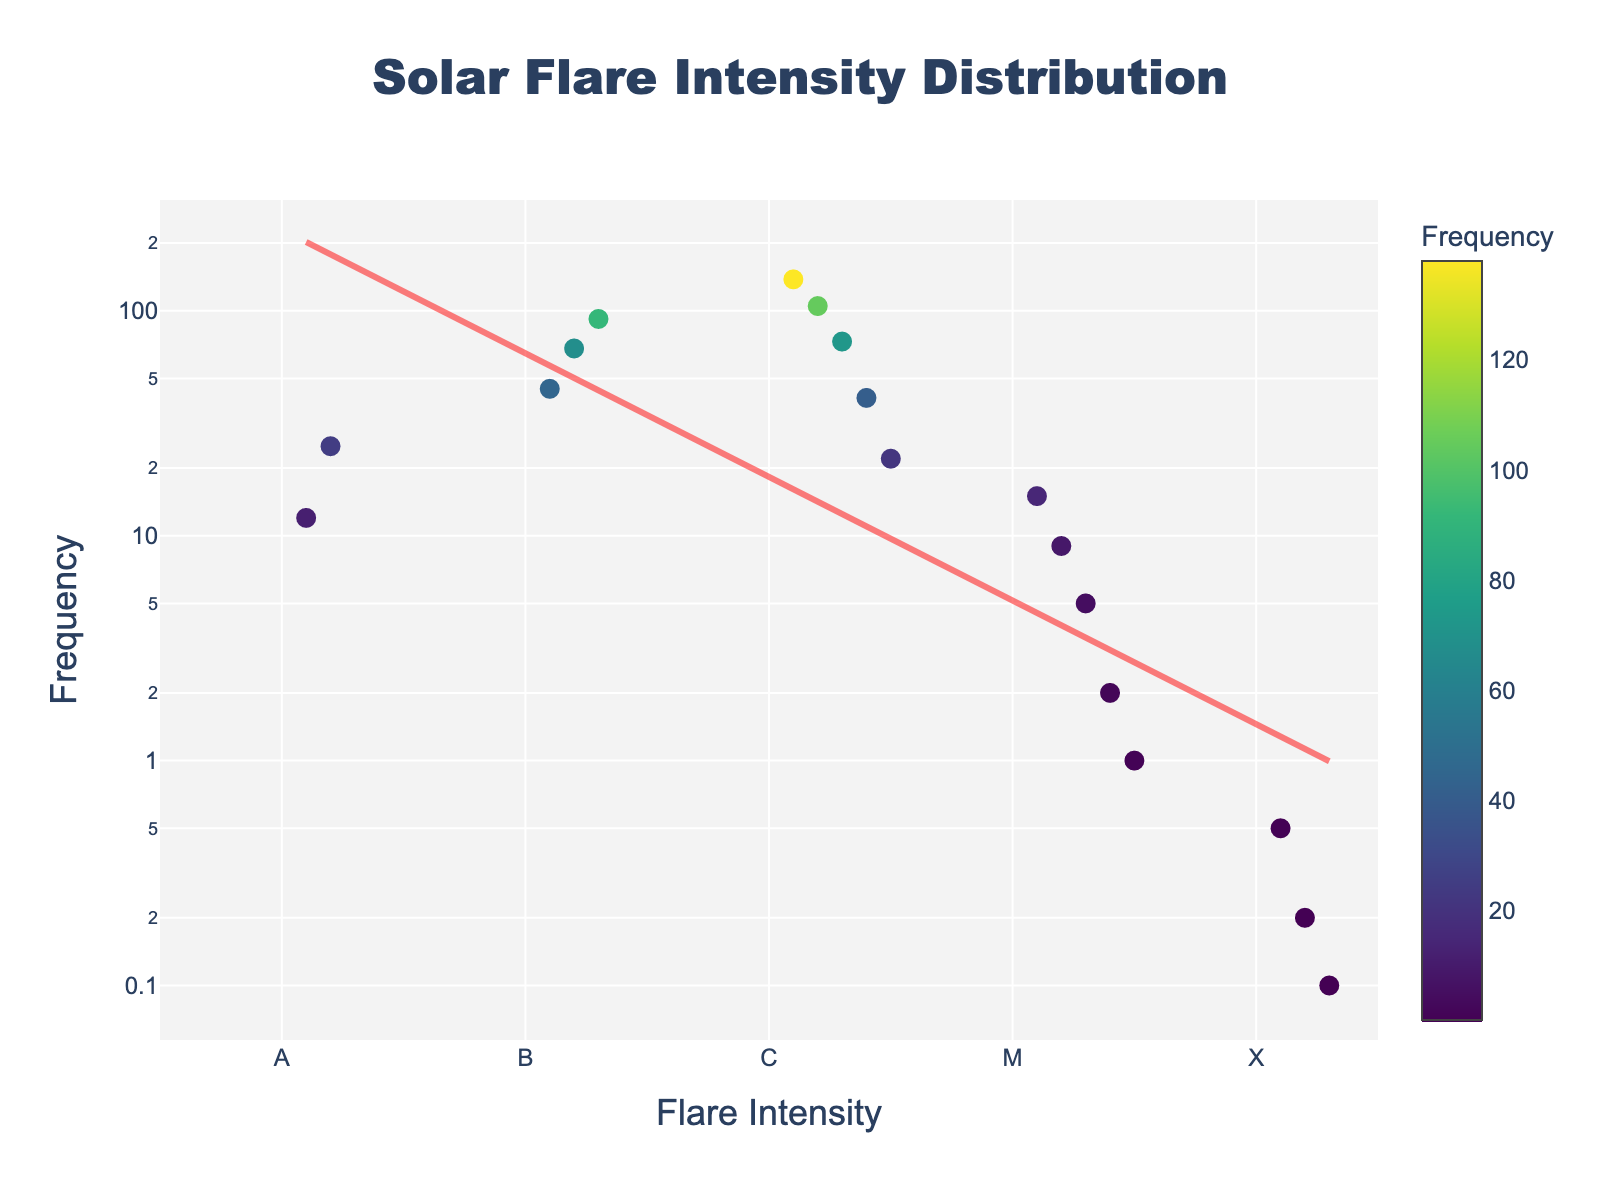what is the title of the plot? The text at the top center of the plot displays the title. It states: "Solar Flare Intensity Distribution".
Answer: Solar Flare Intensity Distribution What is the frequency of solar flares with intensity M1? Hovering over the marker labeled 'M1' reveals the frequency displayed next to the intensity level. It shows a frequency of 15.
Answer: 15 What is the intensity class with the highest frequency? By looking at the vertical axis and identifying the tallest point on the marker plot, we see that the intensity labeled 'C1' has the highest frequency of 138.
Answer: C1 Which intensity class shows the lowest recorded frequency? Observing the markers on the plot, the intensity labeled 'X3' has the smallest value at 0.1.
Answer: X3 Are there any intensity classes with zero frequency? By checking that all markers representing different intensities are above zero on the vertical axis, there are no zero frequencies present in the plot.
Answer: None What is the overall trend shown by the best fit line in terms of intensity and frequency? The best fit line slopes downward from left to right, indicating that as intensity increases, frequency decreases. This aligns with the exponential decay observed.
Answer: Decreasing Which intensity class shows the most significant decrease in frequency compared to the previous class? Comparing the marker heights visually, the transition from B3 (92) to C1 (138) shows an increase, while going from C2 (105) to the next classes 'C3' or 'M1' shows a stark drop. However, M1 to M2 decreases the most significantly from 15 to 9.
Answer: B3 to C1 How does the frequency of flare intensities in category 'M' compare to the other categories? By analyzing the plot, the frequencies for 'M' class fall consistently lower than 'C' and 'B', indicating significantly rarer events as we go from M1 to M5.
Answer: Lower If you sum the frequencies of all 'X' class solar flares, what value do you get? Adding the frequencies of X1, X2, and X3 (0.5 + 0.2 + 0.1), we get 0.8.
Answer: 0.8 What is the color scale used for the markers on the plot? The color of the markers changes based on frequency, and refers to the 'Viridis' color scale, which ranges from deep purple at the lowest frequencies to bright yellow at the highest.
Answer: Viridis 